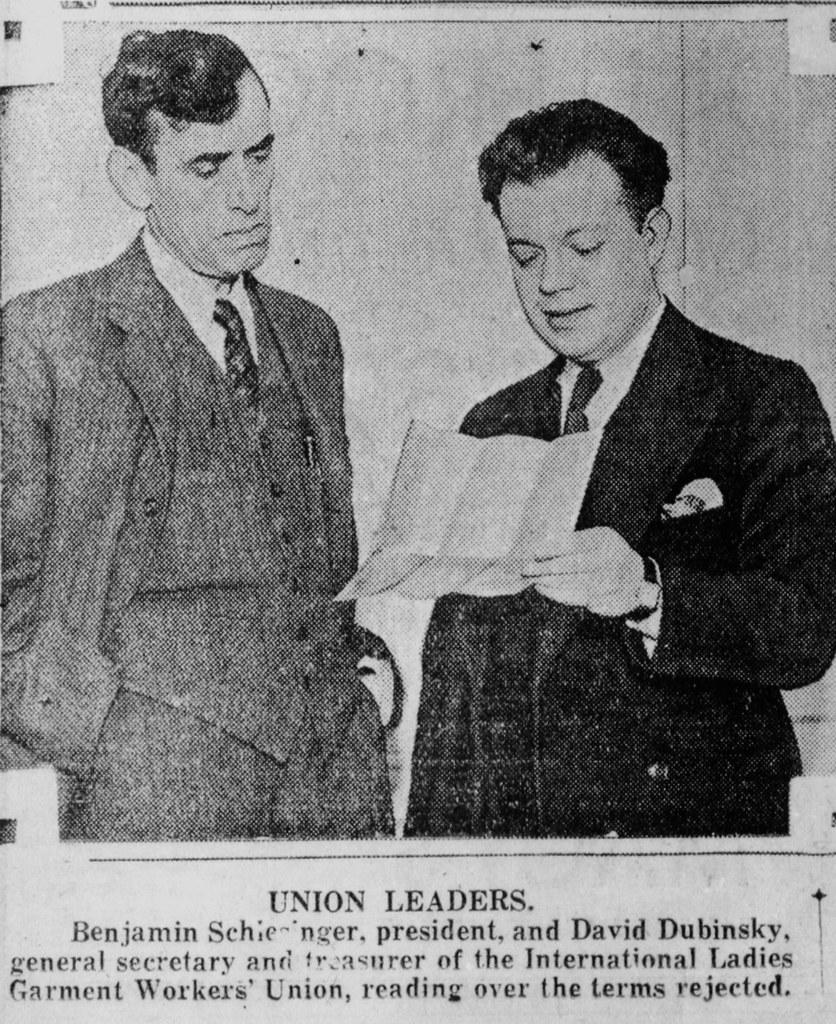What is the color scheme of the image? The image is black and white. How many people are in the image? There are two persons in the center of the image. Is there any text present in the image? Yes, there is text at the bottom of the image. How many ants can be seen crawling on the lip in the image? There are no ants or lips present in the image; it is a black and white image featuring two persons in the center and text at the bottom. 